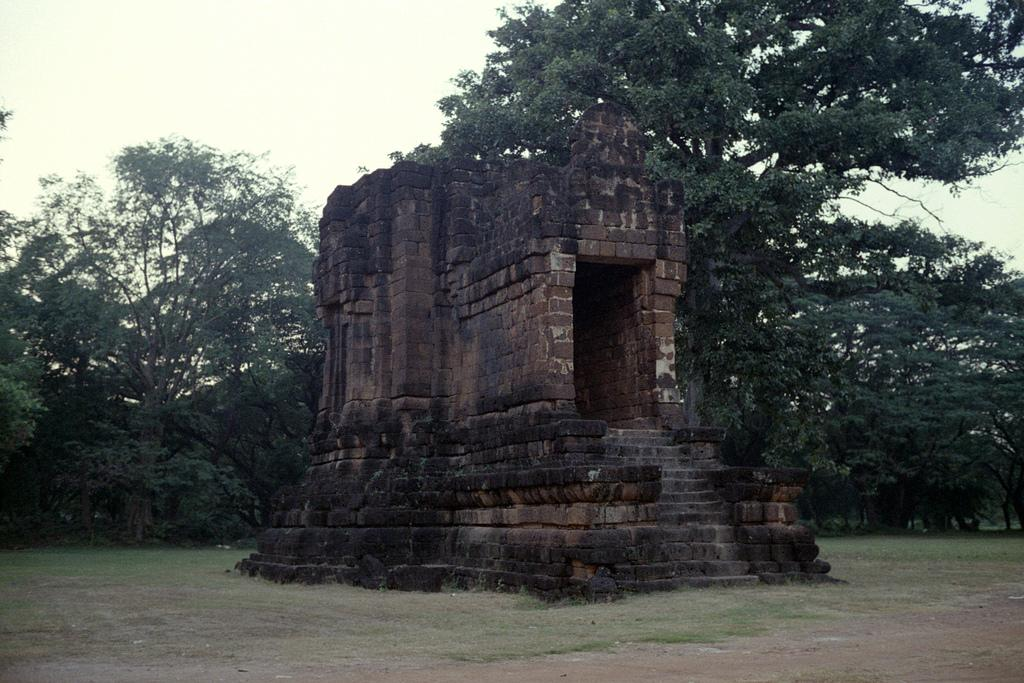What type of structure is depicted in the image? There is an ancient architecture in the image. What material is the structure made of? The architecture is made of a brick wall. What can be seen on the ground in the image? Some grass is visible on the ground. What is visible in the background of the image? There are a few trees visible in the background. What type of needle is being used by the minister in the image? There is no minister or needle present in the image. The image features ancient architecture and its surroundings. 